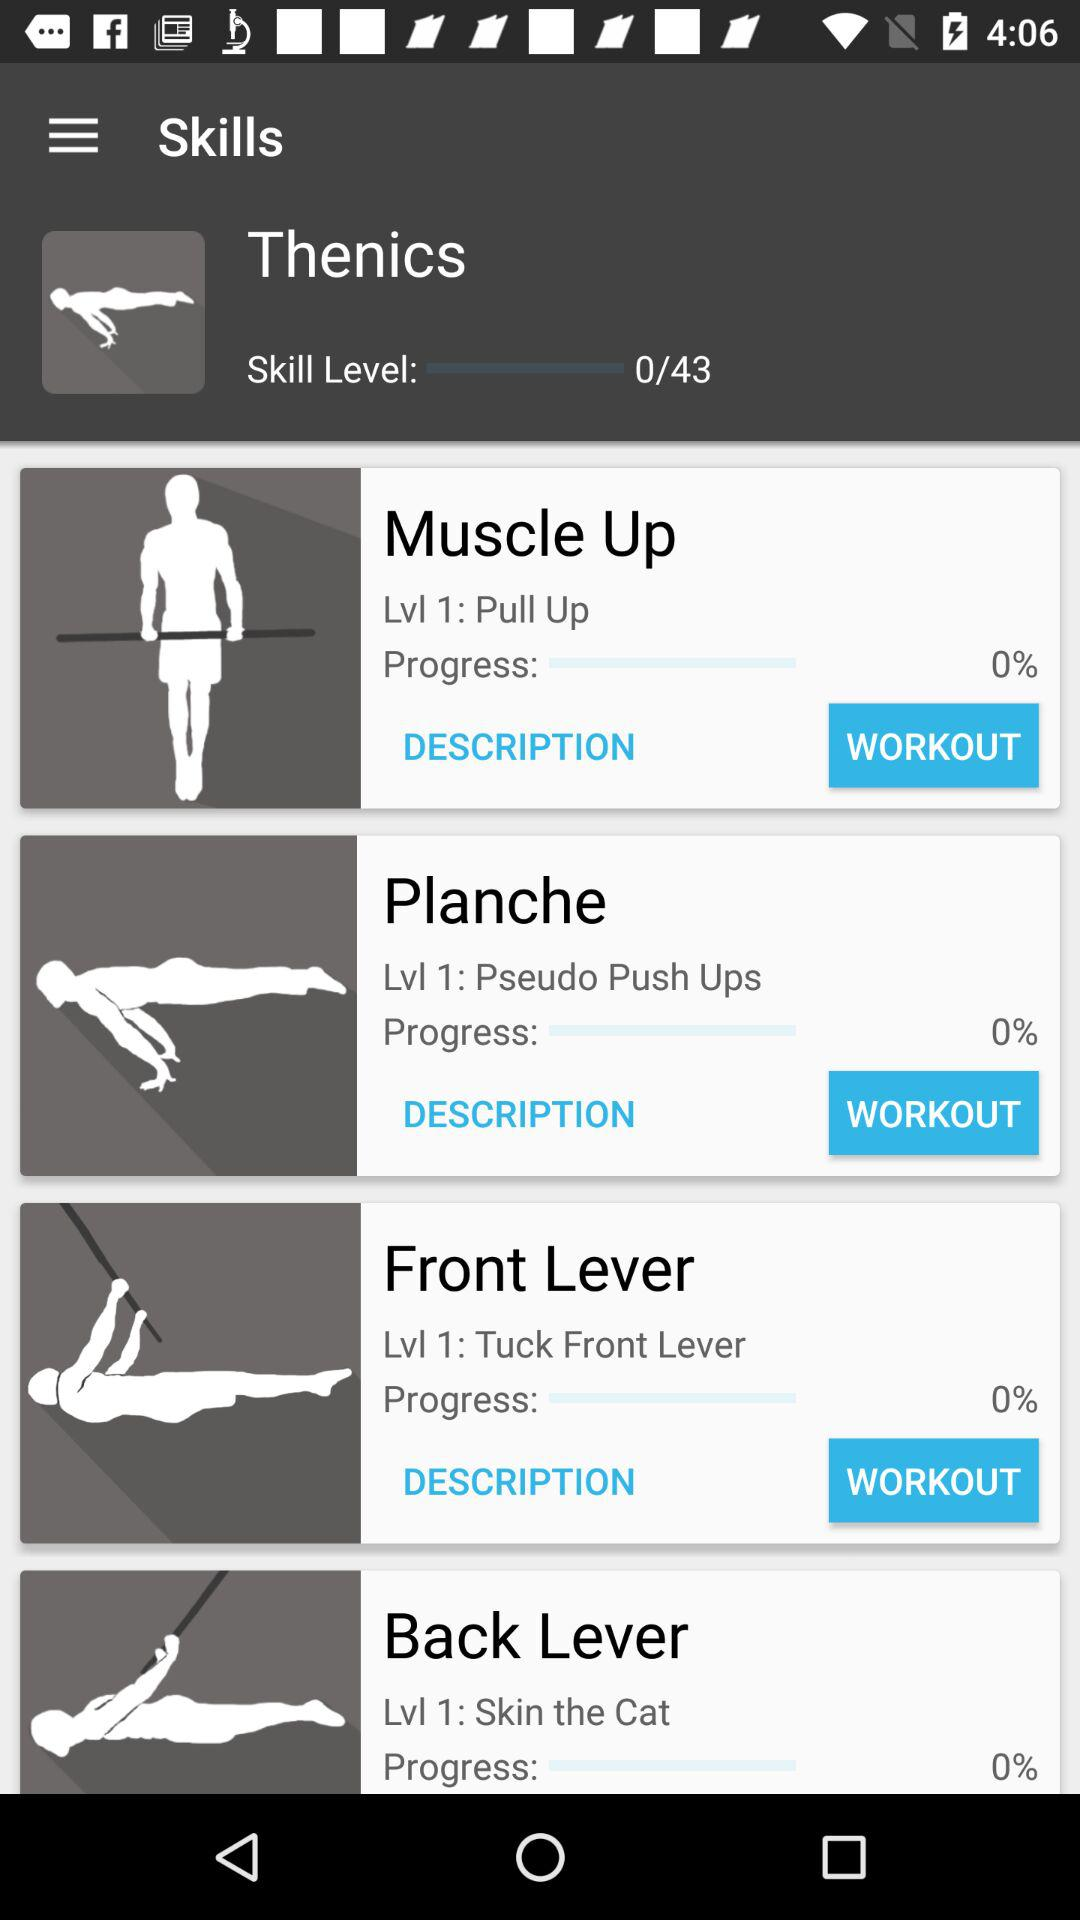What is the progress of "Muscle Up"? The progress is 0%. 